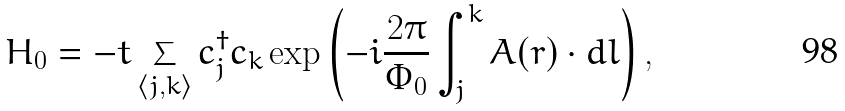<formula> <loc_0><loc_0><loc_500><loc_500>H _ { 0 } = - t \sum _ { \left < j , k \right > } c _ { j } ^ { \dagger } c _ { k } \exp \left ( - i \frac { 2 \pi } { \Phi _ { 0 } } \int _ { j } ^ { k } A ( r ) \cdot d l \right ) ,</formula> 